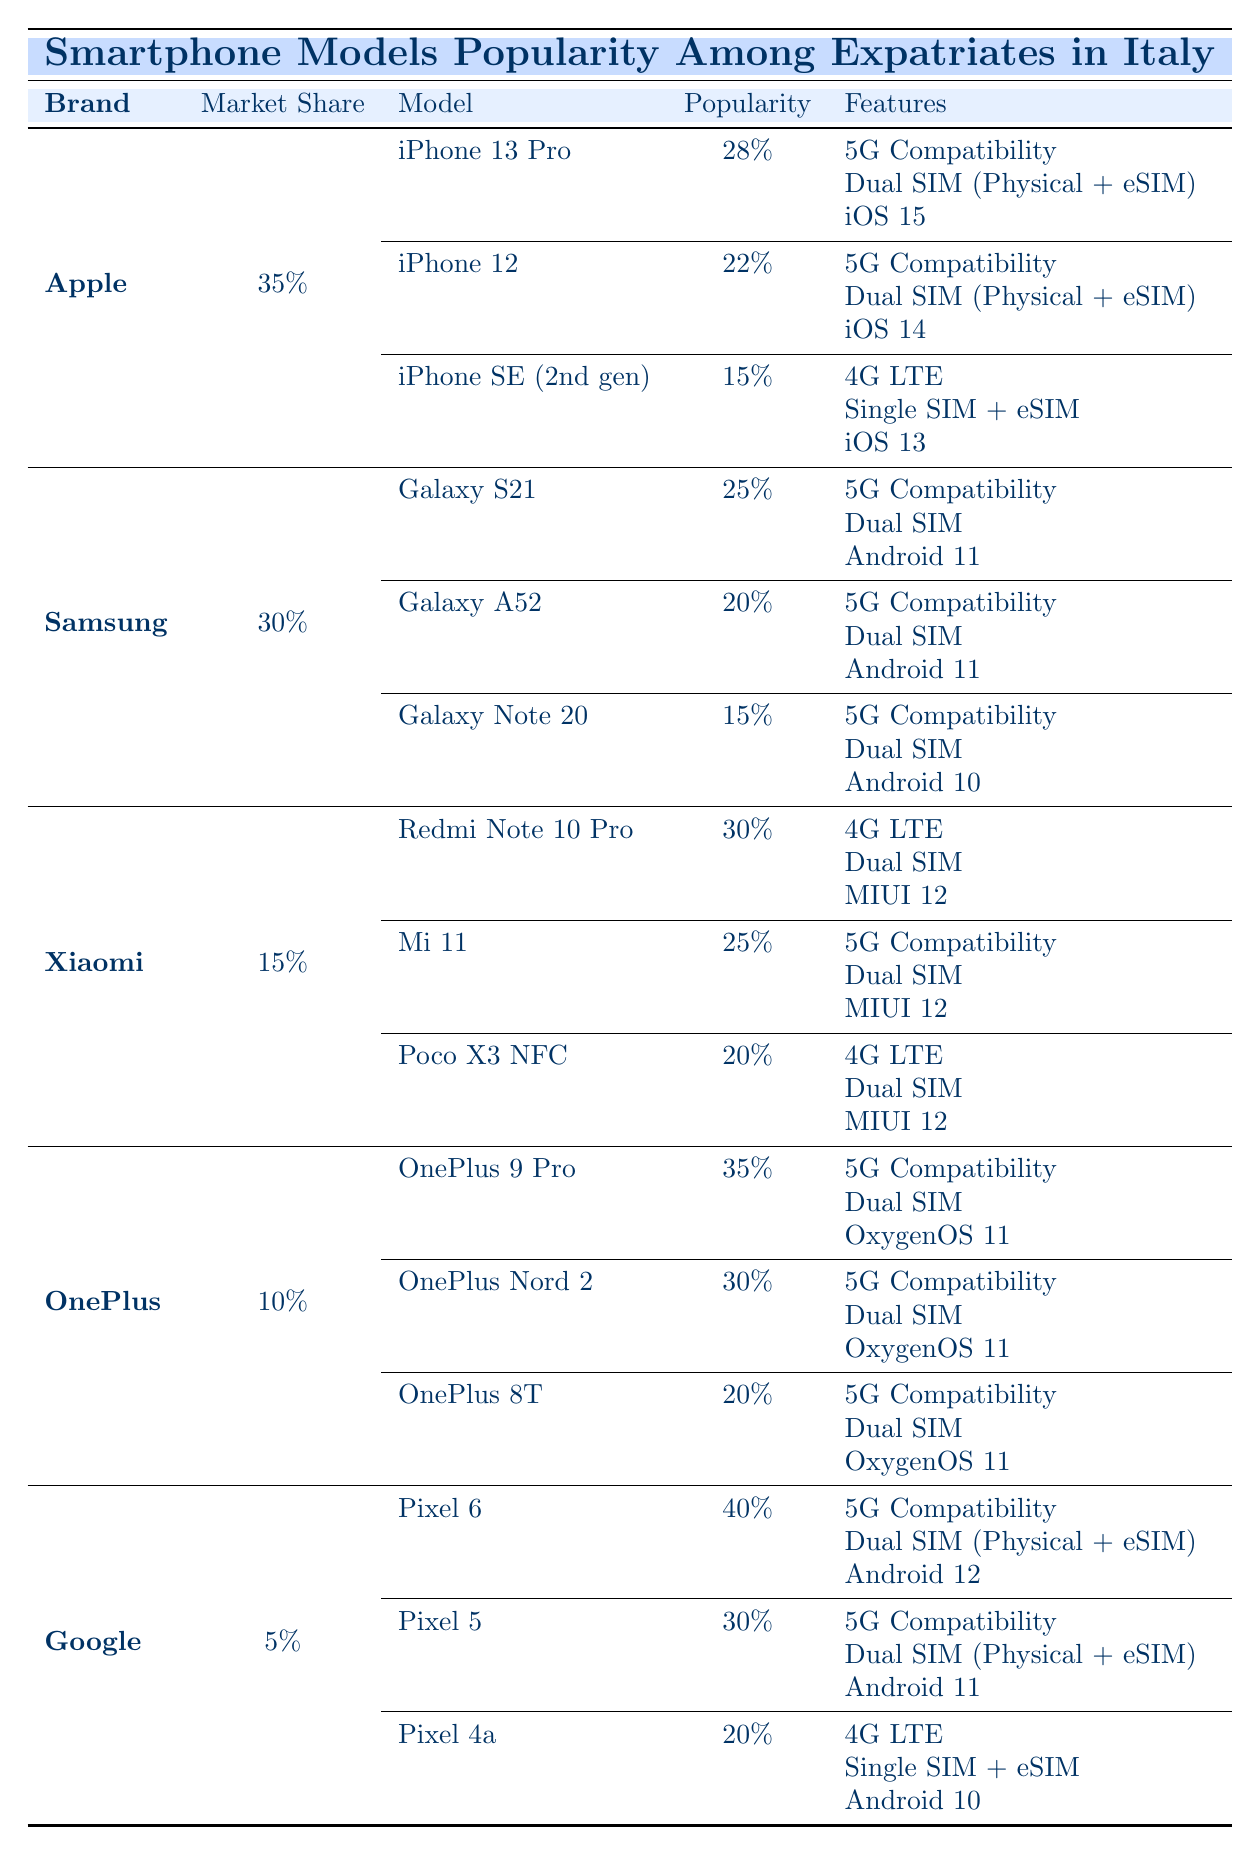What is the most popular smartphone model among expatriates in Italy? The table shows that the Pixel 6, with a popularity of 40%, is the most popular smartphone model among expatriates in Italy.
Answer: Pixel 6 Which brand has the highest market share? According to the table, Apple has the highest market share at 35%.
Answer: Apple How many models from Samsung are listed in the table? There are three Samsung models listed: Galaxy S21, Galaxy A52, and Galaxy Note 20.
Answer: 3 What features does the iPhone SE (2nd gen) have? The iPhone SE (2nd gen) has features including 4G LTE, Single SIM + eSIM, and iOS 13.
Answer: 4G LTE, Single SIM + eSIM, iOS 13 What is the combined popularity of the OnePlus models? Adding the popularity of the OnePlus models (35% + 30% + 20%) gives a total of 85%.
Answer: 85% Is the Samsung Galaxy Note 20 more popular than the Xiaomi Redmi Note 10 Pro? The Galaxy Note 20 has a popularity of 15%, while the Redmi Note 10 Pro is more popular at 30%.
Answer: No Which brand has the lowest market share, and what is its percentage? Google has the lowest market share at 5%.
Answer: Google, 5% How many Apple models have a popularity of 20% or higher? The iPhone 13 Pro (28%), iPhone 12 (22%), and iPhone SE (2nd gen) (15%) give a total of 2 models with 20% or higher popularity.
Answer: 2 What percentage of expatriates prefer the Google Pixel 5 over the OnePlus 8T? The Pixel 5 has a popularity of 30%, while OnePlus 8T is at 20%, so 30% - 20% = 10% more expatriates prefer Pixel 5.
Answer: 10% Which brand has the most dual SIM smartphone models? Apple, Samsung, Xiaomi, OnePlus, and Google all have dual SIM models, but Samsung only lists dual SIM for 3 models and Xiaomi for 2, so no brand has more than 3.
Answer: Apple, Samsung, Xiaomi, OnePlus, Google (tie) 